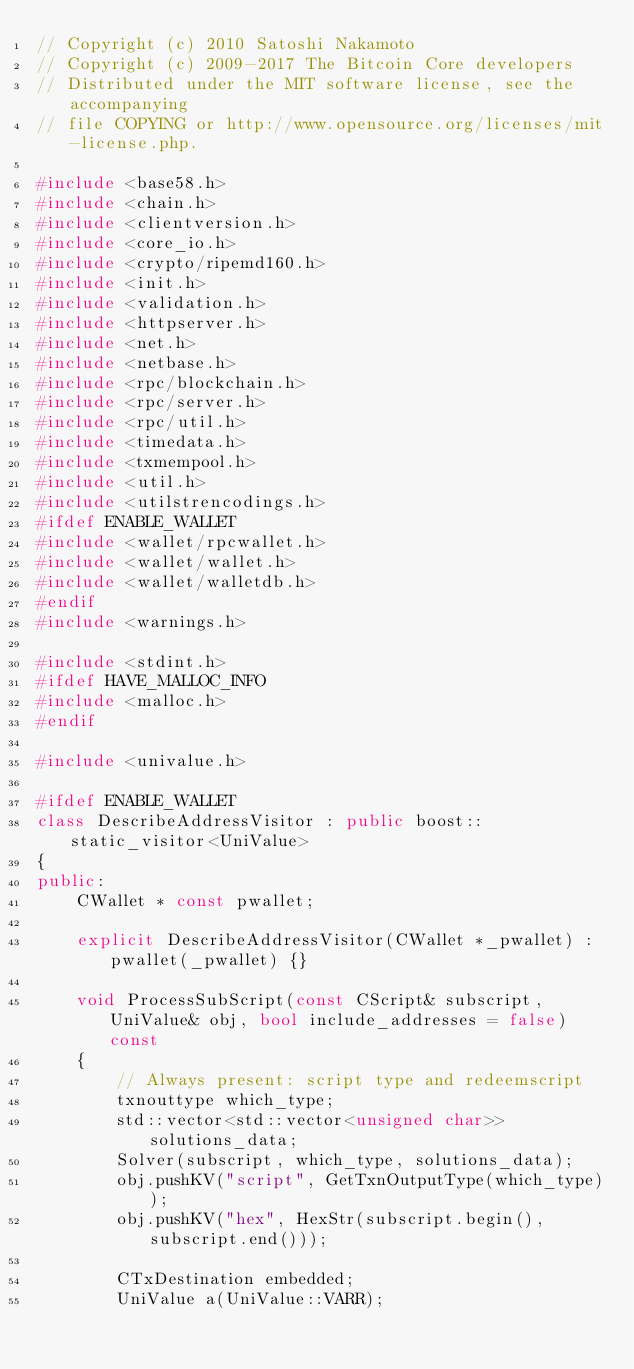Convert code to text. <code><loc_0><loc_0><loc_500><loc_500><_C++_>// Copyright (c) 2010 Satoshi Nakamoto
// Copyright (c) 2009-2017 The Bitcoin Core developers
// Distributed under the MIT software license, see the accompanying
// file COPYING or http://www.opensource.org/licenses/mit-license.php.

#include <base58.h>
#include <chain.h>
#include <clientversion.h>
#include <core_io.h>
#include <crypto/ripemd160.h>
#include <init.h>
#include <validation.h>
#include <httpserver.h>
#include <net.h>
#include <netbase.h>
#include <rpc/blockchain.h>
#include <rpc/server.h>
#include <rpc/util.h>
#include <timedata.h>
#include <txmempool.h>
#include <util.h>
#include <utilstrencodings.h>
#ifdef ENABLE_WALLET
#include <wallet/rpcwallet.h>
#include <wallet/wallet.h>
#include <wallet/walletdb.h>
#endif
#include <warnings.h>

#include <stdint.h>
#ifdef HAVE_MALLOC_INFO
#include <malloc.h>
#endif

#include <univalue.h>

#ifdef ENABLE_WALLET
class DescribeAddressVisitor : public boost::static_visitor<UniValue>
{
public:
    CWallet * const pwallet;

    explicit DescribeAddressVisitor(CWallet *_pwallet) : pwallet(_pwallet) {}

    void ProcessSubScript(const CScript& subscript, UniValue& obj, bool include_addresses = false) const
    {
        // Always present: script type and redeemscript
        txnouttype which_type;
        std::vector<std::vector<unsigned char>> solutions_data;
        Solver(subscript, which_type, solutions_data);
        obj.pushKV("script", GetTxnOutputType(which_type));
        obj.pushKV("hex", HexStr(subscript.begin(), subscript.end()));

        CTxDestination embedded;
        UniValue a(UniValue::VARR);</code> 